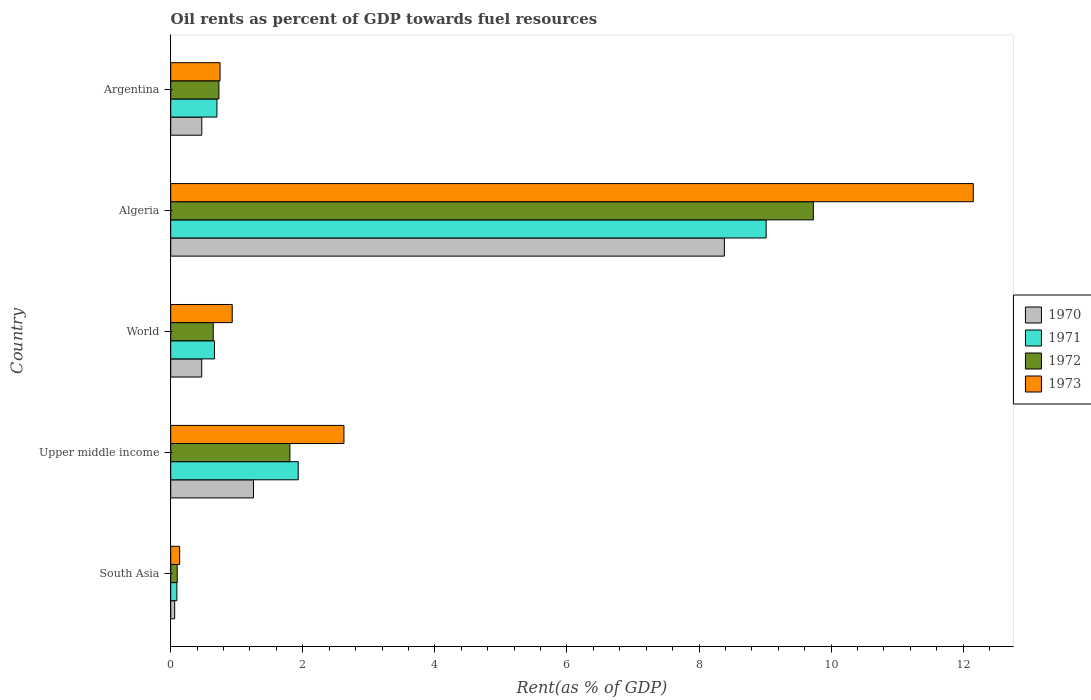How many different coloured bars are there?
Offer a terse response. 4. How many groups of bars are there?
Offer a terse response. 5. Are the number of bars on each tick of the Y-axis equal?
Offer a very short reply. Yes. What is the label of the 2nd group of bars from the top?
Make the answer very short. Algeria. What is the oil rent in 1970 in Upper middle income?
Your answer should be very brief. 1.25. Across all countries, what is the maximum oil rent in 1972?
Keep it short and to the point. 9.73. Across all countries, what is the minimum oil rent in 1973?
Give a very brief answer. 0.14. In which country was the oil rent in 1970 maximum?
Offer a terse response. Algeria. In which country was the oil rent in 1970 minimum?
Provide a succinct answer. South Asia. What is the total oil rent in 1973 in the graph?
Offer a very short reply. 16.59. What is the difference between the oil rent in 1973 in South Asia and that in World?
Ensure brevity in your answer.  -0.8. What is the difference between the oil rent in 1971 in South Asia and the oil rent in 1973 in World?
Provide a succinct answer. -0.84. What is the average oil rent in 1972 per country?
Your answer should be very brief. 2.6. What is the difference between the oil rent in 1972 and oil rent in 1970 in World?
Provide a short and direct response. 0.17. What is the ratio of the oil rent in 1972 in Argentina to that in Upper middle income?
Make the answer very short. 0.4. What is the difference between the highest and the second highest oil rent in 1971?
Your answer should be compact. 7.09. What is the difference between the highest and the lowest oil rent in 1972?
Give a very brief answer. 9.63. Is the sum of the oil rent in 1970 in Argentina and World greater than the maximum oil rent in 1971 across all countries?
Keep it short and to the point. No. Is it the case that in every country, the sum of the oil rent in 1972 and oil rent in 1970 is greater than the sum of oil rent in 1973 and oil rent in 1971?
Ensure brevity in your answer.  No. What does the 2nd bar from the bottom in Upper middle income represents?
Give a very brief answer. 1971. How many bars are there?
Provide a succinct answer. 20. What is the difference between two consecutive major ticks on the X-axis?
Ensure brevity in your answer.  2. Does the graph contain any zero values?
Offer a very short reply. No. Does the graph contain grids?
Ensure brevity in your answer.  No. Where does the legend appear in the graph?
Keep it short and to the point. Center right. How many legend labels are there?
Offer a very short reply. 4. What is the title of the graph?
Offer a very short reply. Oil rents as percent of GDP towards fuel resources. Does "1961" appear as one of the legend labels in the graph?
Your answer should be compact. No. What is the label or title of the X-axis?
Your answer should be very brief. Rent(as % of GDP). What is the Rent(as % of GDP) in 1970 in South Asia?
Ensure brevity in your answer.  0.06. What is the Rent(as % of GDP) of 1971 in South Asia?
Offer a very short reply. 0.09. What is the Rent(as % of GDP) of 1972 in South Asia?
Make the answer very short. 0.1. What is the Rent(as % of GDP) of 1973 in South Asia?
Your response must be concise. 0.14. What is the Rent(as % of GDP) of 1970 in Upper middle income?
Provide a short and direct response. 1.25. What is the Rent(as % of GDP) in 1971 in Upper middle income?
Ensure brevity in your answer.  1.93. What is the Rent(as % of GDP) of 1972 in Upper middle income?
Provide a succinct answer. 1.8. What is the Rent(as % of GDP) in 1973 in Upper middle income?
Make the answer very short. 2.62. What is the Rent(as % of GDP) of 1970 in World?
Offer a very short reply. 0.47. What is the Rent(as % of GDP) of 1971 in World?
Your answer should be very brief. 0.66. What is the Rent(as % of GDP) in 1972 in World?
Make the answer very short. 0.64. What is the Rent(as % of GDP) of 1973 in World?
Make the answer very short. 0.93. What is the Rent(as % of GDP) in 1970 in Algeria?
Your answer should be very brief. 8.38. What is the Rent(as % of GDP) of 1971 in Algeria?
Provide a short and direct response. 9.02. What is the Rent(as % of GDP) of 1972 in Algeria?
Keep it short and to the point. 9.73. What is the Rent(as % of GDP) in 1973 in Algeria?
Give a very brief answer. 12.15. What is the Rent(as % of GDP) in 1970 in Argentina?
Provide a short and direct response. 0.47. What is the Rent(as % of GDP) in 1971 in Argentina?
Provide a short and direct response. 0.7. What is the Rent(as % of GDP) of 1972 in Argentina?
Make the answer very short. 0.73. What is the Rent(as % of GDP) in 1973 in Argentina?
Provide a succinct answer. 0.75. Across all countries, what is the maximum Rent(as % of GDP) of 1970?
Make the answer very short. 8.38. Across all countries, what is the maximum Rent(as % of GDP) in 1971?
Your response must be concise. 9.02. Across all countries, what is the maximum Rent(as % of GDP) in 1972?
Your answer should be very brief. 9.73. Across all countries, what is the maximum Rent(as % of GDP) in 1973?
Keep it short and to the point. 12.15. Across all countries, what is the minimum Rent(as % of GDP) of 1970?
Provide a succinct answer. 0.06. Across all countries, what is the minimum Rent(as % of GDP) of 1971?
Your response must be concise. 0.09. Across all countries, what is the minimum Rent(as % of GDP) of 1972?
Ensure brevity in your answer.  0.1. Across all countries, what is the minimum Rent(as % of GDP) of 1973?
Provide a short and direct response. 0.14. What is the total Rent(as % of GDP) of 1970 in the graph?
Give a very brief answer. 10.64. What is the total Rent(as % of GDP) in 1971 in the graph?
Keep it short and to the point. 12.4. What is the total Rent(as % of GDP) of 1972 in the graph?
Your response must be concise. 13.01. What is the total Rent(as % of GDP) in 1973 in the graph?
Provide a short and direct response. 16.59. What is the difference between the Rent(as % of GDP) in 1970 in South Asia and that in Upper middle income?
Give a very brief answer. -1.19. What is the difference between the Rent(as % of GDP) in 1971 in South Asia and that in Upper middle income?
Your answer should be very brief. -1.84. What is the difference between the Rent(as % of GDP) in 1972 in South Asia and that in Upper middle income?
Provide a succinct answer. -1.71. What is the difference between the Rent(as % of GDP) in 1973 in South Asia and that in Upper middle income?
Offer a very short reply. -2.49. What is the difference between the Rent(as % of GDP) in 1970 in South Asia and that in World?
Your answer should be very brief. -0.41. What is the difference between the Rent(as % of GDP) in 1971 in South Asia and that in World?
Provide a succinct answer. -0.57. What is the difference between the Rent(as % of GDP) in 1972 in South Asia and that in World?
Make the answer very short. -0.55. What is the difference between the Rent(as % of GDP) in 1973 in South Asia and that in World?
Your response must be concise. -0.8. What is the difference between the Rent(as % of GDP) of 1970 in South Asia and that in Algeria?
Ensure brevity in your answer.  -8.32. What is the difference between the Rent(as % of GDP) of 1971 in South Asia and that in Algeria?
Provide a succinct answer. -8.92. What is the difference between the Rent(as % of GDP) in 1972 in South Asia and that in Algeria?
Provide a succinct answer. -9.63. What is the difference between the Rent(as % of GDP) of 1973 in South Asia and that in Algeria?
Your response must be concise. -12.02. What is the difference between the Rent(as % of GDP) in 1970 in South Asia and that in Argentina?
Your answer should be compact. -0.41. What is the difference between the Rent(as % of GDP) in 1971 in South Asia and that in Argentina?
Provide a short and direct response. -0.61. What is the difference between the Rent(as % of GDP) of 1972 in South Asia and that in Argentina?
Provide a short and direct response. -0.63. What is the difference between the Rent(as % of GDP) in 1973 in South Asia and that in Argentina?
Your answer should be compact. -0.61. What is the difference between the Rent(as % of GDP) of 1970 in Upper middle income and that in World?
Offer a very short reply. 0.78. What is the difference between the Rent(as % of GDP) in 1971 in Upper middle income and that in World?
Your response must be concise. 1.27. What is the difference between the Rent(as % of GDP) in 1972 in Upper middle income and that in World?
Your answer should be very brief. 1.16. What is the difference between the Rent(as % of GDP) in 1973 in Upper middle income and that in World?
Ensure brevity in your answer.  1.69. What is the difference between the Rent(as % of GDP) in 1970 in Upper middle income and that in Algeria?
Offer a terse response. -7.13. What is the difference between the Rent(as % of GDP) in 1971 in Upper middle income and that in Algeria?
Provide a short and direct response. -7.09. What is the difference between the Rent(as % of GDP) in 1972 in Upper middle income and that in Algeria?
Make the answer very short. -7.93. What is the difference between the Rent(as % of GDP) in 1973 in Upper middle income and that in Algeria?
Your answer should be compact. -9.53. What is the difference between the Rent(as % of GDP) of 1970 in Upper middle income and that in Argentina?
Ensure brevity in your answer.  0.78. What is the difference between the Rent(as % of GDP) in 1971 in Upper middle income and that in Argentina?
Keep it short and to the point. 1.23. What is the difference between the Rent(as % of GDP) of 1972 in Upper middle income and that in Argentina?
Ensure brevity in your answer.  1.07. What is the difference between the Rent(as % of GDP) of 1973 in Upper middle income and that in Argentina?
Offer a very short reply. 1.88. What is the difference between the Rent(as % of GDP) of 1970 in World and that in Algeria?
Offer a terse response. -7.91. What is the difference between the Rent(as % of GDP) in 1971 in World and that in Algeria?
Provide a succinct answer. -8.35. What is the difference between the Rent(as % of GDP) of 1972 in World and that in Algeria?
Your answer should be very brief. -9.09. What is the difference between the Rent(as % of GDP) in 1973 in World and that in Algeria?
Offer a very short reply. -11.22. What is the difference between the Rent(as % of GDP) of 1970 in World and that in Argentina?
Make the answer very short. -0. What is the difference between the Rent(as % of GDP) in 1971 in World and that in Argentina?
Offer a very short reply. -0.04. What is the difference between the Rent(as % of GDP) of 1972 in World and that in Argentina?
Ensure brevity in your answer.  -0.09. What is the difference between the Rent(as % of GDP) in 1973 in World and that in Argentina?
Make the answer very short. 0.18. What is the difference between the Rent(as % of GDP) in 1970 in Algeria and that in Argentina?
Your answer should be compact. 7.91. What is the difference between the Rent(as % of GDP) of 1971 in Algeria and that in Argentina?
Ensure brevity in your answer.  8.32. What is the difference between the Rent(as % of GDP) in 1972 in Algeria and that in Argentina?
Ensure brevity in your answer.  9. What is the difference between the Rent(as % of GDP) of 1973 in Algeria and that in Argentina?
Keep it short and to the point. 11.41. What is the difference between the Rent(as % of GDP) of 1970 in South Asia and the Rent(as % of GDP) of 1971 in Upper middle income?
Your answer should be very brief. -1.87. What is the difference between the Rent(as % of GDP) in 1970 in South Asia and the Rent(as % of GDP) in 1972 in Upper middle income?
Provide a succinct answer. -1.74. What is the difference between the Rent(as % of GDP) in 1970 in South Asia and the Rent(as % of GDP) in 1973 in Upper middle income?
Your response must be concise. -2.56. What is the difference between the Rent(as % of GDP) of 1971 in South Asia and the Rent(as % of GDP) of 1972 in Upper middle income?
Provide a succinct answer. -1.71. What is the difference between the Rent(as % of GDP) of 1971 in South Asia and the Rent(as % of GDP) of 1973 in Upper middle income?
Provide a succinct answer. -2.53. What is the difference between the Rent(as % of GDP) of 1972 in South Asia and the Rent(as % of GDP) of 1973 in Upper middle income?
Your answer should be compact. -2.52. What is the difference between the Rent(as % of GDP) in 1970 in South Asia and the Rent(as % of GDP) in 1971 in World?
Offer a terse response. -0.6. What is the difference between the Rent(as % of GDP) of 1970 in South Asia and the Rent(as % of GDP) of 1972 in World?
Your response must be concise. -0.58. What is the difference between the Rent(as % of GDP) of 1970 in South Asia and the Rent(as % of GDP) of 1973 in World?
Your answer should be compact. -0.87. What is the difference between the Rent(as % of GDP) in 1971 in South Asia and the Rent(as % of GDP) in 1972 in World?
Offer a very short reply. -0.55. What is the difference between the Rent(as % of GDP) of 1971 in South Asia and the Rent(as % of GDP) of 1973 in World?
Offer a terse response. -0.84. What is the difference between the Rent(as % of GDP) of 1972 in South Asia and the Rent(as % of GDP) of 1973 in World?
Keep it short and to the point. -0.83. What is the difference between the Rent(as % of GDP) of 1970 in South Asia and the Rent(as % of GDP) of 1971 in Algeria?
Ensure brevity in your answer.  -8.96. What is the difference between the Rent(as % of GDP) of 1970 in South Asia and the Rent(as % of GDP) of 1972 in Algeria?
Give a very brief answer. -9.67. What is the difference between the Rent(as % of GDP) in 1970 in South Asia and the Rent(as % of GDP) in 1973 in Algeria?
Your answer should be very brief. -12.09. What is the difference between the Rent(as % of GDP) in 1971 in South Asia and the Rent(as % of GDP) in 1972 in Algeria?
Provide a short and direct response. -9.64. What is the difference between the Rent(as % of GDP) of 1971 in South Asia and the Rent(as % of GDP) of 1973 in Algeria?
Your answer should be compact. -12.06. What is the difference between the Rent(as % of GDP) in 1972 in South Asia and the Rent(as % of GDP) in 1973 in Algeria?
Ensure brevity in your answer.  -12.05. What is the difference between the Rent(as % of GDP) of 1970 in South Asia and the Rent(as % of GDP) of 1971 in Argentina?
Provide a succinct answer. -0.64. What is the difference between the Rent(as % of GDP) in 1970 in South Asia and the Rent(as % of GDP) in 1972 in Argentina?
Provide a short and direct response. -0.67. What is the difference between the Rent(as % of GDP) in 1970 in South Asia and the Rent(as % of GDP) in 1973 in Argentina?
Provide a short and direct response. -0.69. What is the difference between the Rent(as % of GDP) of 1971 in South Asia and the Rent(as % of GDP) of 1972 in Argentina?
Make the answer very short. -0.64. What is the difference between the Rent(as % of GDP) of 1971 in South Asia and the Rent(as % of GDP) of 1973 in Argentina?
Offer a very short reply. -0.65. What is the difference between the Rent(as % of GDP) of 1972 in South Asia and the Rent(as % of GDP) of 1973 in Argentina?
Your answer should be compact. -0.65. What is the difference between the Rent(as % of GDP) in 1970 in Upper middle income and the Rent(as % of GDP) in 1971 in World?
Offer a terse response. 0.59. What is the difference between the Rent(as % of GDP) of 1970 in Upper middle income and the Rent(as % of GDP) of 1972 in World?
Your response must be concise. 0.61. What is the difference between the Rent(as % of GDP) in 1970 in Upper middle income and the Rent(as % of GDP) in 1973 in World?
Your answer should be compact. 0.32. What is the difference between the Rent(as % of GDP) in 1971 in Upper middle income and the Rent(as % of GDP) in 1972 in World?
Provide a succinct answer. 1.29. What is the difference between the Rent(as % of GDP) of 1971 in Upper middle income and the Rent(as % of GDP) of 1973 in World?
Make the answer very short. 1. What is the difference between the Rent(as % of GDP) in 1972 in Upper middle income and the Rent(as % of GDP) in 1973 in World?
Your answer should be very brief. 0.87. What is the difference between the Rent(as % of GDP) of 1970 in Upper middle income and the Rent(as % of GDP) of 1971 in Algeria?
Ensure brevity in your answer.  -7.76. What is the difference between the Rent(as % of GDP) in 1970 in Upper middle income and the Rent(as % of GDP) in 1972 in Algeria?
Offer a very short reply. -8.48. What is the difference between the Rent(as % of GDP) in 1970 in Upper middle income and the Rent(as % of GDP) in 1973 in Algeria?
Provide a succinct answer. -10.9. What is the difference between the Rent(as % of GDP) in 1971 in Upper middle income and the Rent(as % of GDP) in 1973 in Algeria?
Give a very brief answer. -10.22. What is the difference between the Rent(as % of GDP) of 1972 in Upper middle income and the Rent(as % of GDP) of 1973 in Algeria?
Provide a succinct answer. -10.35. What is the difference between the Rent(as % of GDP) of 1970 in Upper middle income and the Rent(as % of GDP) of 1971 in Argentina?
Ensure brevity in your answer.  0.55. What is the difference between the Rent(as % of GDP) of 1970 in Upper middle income and the Rent(as % of GDP) of 1972 in Argentina?
Offer a very short reply. 0.52. What is the difference between the Rent(as % of GDP) of 1970 in Upper middle income and the Rent(as % of GDP) of 1973 in Argentina?
Keep it short and to the point. 0.51. What is the difference between the Rent(as % of GDP) of 1971 in Upper middle income and the Rent(as % of GDP) of 1972 in Argentina?
Your answer should be very brief. 1.2. What is the difference between the Rent(as % of GDP) of 1971 in Upper middle income and the Rent(as % of GDP) of 1973 in Argentina?
Keep it short and to the point. 1.18. What is the difference between the Rent(as % of GDP) in 1972 in Upper middle income and the Rent(as % of GDP) in 1973 in Argentina?
Your response must be concise. 1.06. What is the difference between the Rent(as % of GDP) of 1970 in World and the Rent(as % of GDP) of 1971 in Algeria?
Offer a terse response. -8.55. What is the difference between the Rent(as % of GDP) of 1970 in World and the Rent(as % of GDP) of 1972 in Algeria?
Offer a terse response. -9.26. What is the difference between the Rent(as % of GDP) of 1970 in World and the Rent(as % of GDP) of 1973 in Algeria?
Make the answer very short. -11.68. What is the difference between the Rent(as % of GDP) of 1971 in World and the Rent(as % of GDP) of 1972 in Algeria?
Your answer should be compact. -9.07. What is the difference between the Rent(as % of GDP) in 1971 in World and the Rent(as % of GDP) in 1973 in Algeria?
Make the answer very short. -11.49. What is the difference between the Rent(as % of GDP) of 1972 in World and the Rent(as % of GDP) of 1973 in Algeria?
Make the answer very short. -11.51. What is the difference between the Rent(as % of GDP) of 1970 in World and the Rent(as % of GDP) of 1971 in Argentina?
Offer a very short reply. -0.23. What is the difference between the Rent(as % of GDP) of 1970 in World and the Rent(as % of GDP) of 1972 in Argentina?
Your answer should be very brief. -0.26. What is the difference between the Rent(as % of GDP) in 1970 in World and the Rent(as % of GDP) in 1973 in Argentina?
Give a very brief answer. -0.28. What is the difference between the Rent(as % of GDP) in 1971 in World and the Rent(as % of GDP) in 1972 in Argentina?
Ensure brevity in your answer.  -0.07. What is the difference between the Rent(as % of GDP) in 1971 in World and the Rent(as % of GDP) in 1973 in Argentina?
Your response must be concise. -0.08. What is the difference between the Rent(as % of GDP) of 1972 in World and the Rent(as % of GDP) of 1973 in Argentina?
Keep it short and to the point. -0.1. What is the difference between the Rent(as % of GDP) of 1970 in Algeria and the Rent(as % of GDP) of 1971 in Argentina?
Your response must be concise. 7.68. What is the difference between the Rent(as % of GDP) of 1970 in Algeria and the Rent(as % of GDP) of 1972 in Argentina?
Make the answer very short. 7.65. What is the difference between the Rent(as % of GDP) of 1970 in Algeria and the Rent(as % of GDP) of 1973 in Argentina?
Provide a short and direct response. 7.64. What is the difference between the Rent(as % of GDP) of 1971 in Algeria and the Rent(as % of GDP) of 1972 in Argentina?
Offer a very short reply. 8.29. What is the difference between the Rent(as % of GDP) in 1971 in Algeria and the Rent(as % of GDP) in 1973 in Argentina?
Your answer should be compact. 8.27. What is the difference between the Rent(as % of GDP) in 1972 in Algeria and the Rent(as % of GDP) in 1973 in Argentina?
Give a very brief answer. 8.98. What is the average Rent(as % of GDP) in 1970 per country?
Provide a succinct answer. 2.13. What is the average Rent(as % of GDP) of 1971 per country?
Keep it short and to the point. 2.48. What is the average Rent(as % of GDP) in 1972 per country?
Keep it short and to the point. 2.6. What is the average Rent(as % of GDP) of 1973 per country?
Provide a succinct answer. 3.32. What is the difference between the Rent(as % of GDP) of 1970 and Rent(as % of GDP) of 1971 in South Asia?
Give a very brief answer. -0.03. What is the difference between the Rent(as % of GDP) of 1970 and Rent(as % of GDP) of 1972 in South Asia?
Your response must be concise. -0.04. What is the difference between the Rent(as % of GDP) in 1970 and Rent(as % of GDP) in 1973 in South Asia?
Provide a succinct answer. -0.08. What is the difference between the Rent(as % of GDP) of 1971 and Rent(as % of GDP) of 1972 in South Asia?
Provide a succinct answer. -0.01. What is the difference between the Rent(as % of GDP) in 1971 and Rent(as % of GDP) in 1973 in South Asia?
Keep it short and to the point. -0.04. What is the difference between the Rent(as % of GDP) in 1972 and Rent(as % of GDP) in 1973 in South Asia?
Keep it short and to the point. -0.04. What is the difference between the Rent(as % of GDP) in 1970 and Rent(as % of GDP) in 1971 in Upper middle income?
Ensure brevity in your answer.  -0.68. What is the difference between the Rent(as % of GDP) of 1970 and Rent(as % of GDP) of 1972 in Upper middle income?
Provide a succinct answer. -0.55. What is the difference between the Rent(as % of GDP) in 1970 and Rent(as % of GDP) in 1973 in Upper middle income?
Ensure brevity in your answer.  -1.37. What is the difference between the Rent(as % of GDP) of 1971 and Rent(as % of GDP) of 1972 in Upper middle income?
Ensure brevity in your answer.  0.13. What is the difference between the Rent(as % of GDP) in 1971 and Rent(as % of GDP) in 1973 in Upper middle income?
Offer a very short reply. -0.69. What is the difference between the Rent(as % of GDP) in 1972 and Rent(as % of GDP) in 1973 in Upper middle income?
Provide a short and direct response. -0.82. What is the difference between the Rent(as % of GDP) of 1970 and Rent(as % of GDP) of 1971 in World?
Your response must be concise. -0.19. What is the difference between the Rent(as % of GDP) of 1970 and Rent(as % of GDP) of 1972 in World?
Make the answer very short. -0.17. What is the difference between the Rent(as % of GDP) of 1970 and Rent(as % of GDP) of 1973 in World?
Your response must be concise. -0.46. What is the difference between the Rent(as % of GDP) in 1971 and Rent(as % of GDP) in 1972 in World?
Your answer should be compact. 0.02. What is the difference between the Rent(as % of GDP) of 1971 and Rent(as % of GDP) of 1973 in World?
Ensure brevity in your answer.  -0.27. What is the difference between the Rent(as % of GDP) in 1972 and Rent(as % of GDP) in 1973 in World?
Provide a succinct answer. -0.29. What is the difference between the Rent(as % of GDP) in 1970 and Rent(as % of GDP) in 1971 in Algeria?
Offer a terse response. -0.63. What is the difference between the Rent(as % of GDP) in 1970 and Rent(as % of GDP) in 1972 in Algeria?
Ensure brevity in your answer.  -1.35. What is the difference between the Rent(as % of GDP) in 1970 and Rent(as % of GDP) in 1973 in Algeria?
Ensure brevity in your answer.  -3.77. What is the difference between the Rent(as % of GDP) of 1971 and Rent(as % of GDP) of 1972 in Algeria?
Provide a short and direct response. -0.71. What is the difference between the Rent(as % of GDP) of 1971 and Rent(as % of GDP) of 1973 in Algeria?
Make the answer very short. -3.14. What is the difference between the Rent(as % of GDP) of 1972 and Rent(as % of GDP) of 1973 in Algeria?
Your answer should be compact. -2.42. What is the difference between the Rent(as % of GDP) of 1970 and Rent(as % of GDP) of 1971 in Argentina?
Your response must be concise. -0.23. What is the difference between the Rent(as % of GDP) of 1970 and Rent(as % of GDP) of 1972 in Argentina?
Ensure brevity in your answer.  -0.26. What is the difference between the Rent(as % of GDP) of 1970 and Rent(as % of GDP) of 1973 in Argentina?
Offer a very short reply. -0.28. What is the difference between the Rent(as % of GDP) in 1971 and Rent(as % of GDP) in 1972 in Argentina?
Make the answer very short. -0.03. What is the difference between the Rent(as % of GDP) in 1971 and Rent(as % of GDP) in 1973 in Argentina?
Your answer should be compact. -0.05. What is the difference between the Rent(as % of GDP) of 1972 and Rent(as % of GDP) of 1973 in Argentina?
Provide a short and direct response. -0.02. What is the ratio of the Rent(as % of GDP) of 1970 in South Asia to that in Upper middle income?
Keep it short and to the point. 0.05. What is the ratio of the Rent(as % of GDP) of 1971 in South Asia to that in Upper middle income?
Offer a terse response. 0.05. What is the ratio of the Rent(as % of GDP) in 1972 in South Asia to that in Upper middle income?
Provide a short and direct response. 0.05. What is the ratio of the Rent(as % of GDP) in 1973 in South Asia to that in Upper middle income?
Keep it short and to the point. 0.05. What is the ratio of the Rent(as % of GDP) in 1970 in South Asia to that in World?
Ensure brevity in your answer.  0.13. What is the ratio of the Rent(as % of GDP) in 1971 in South Asia to that in World?
Keep it short and to the point. 0.14. What is the ratio of the Rent(as % of GDP) in 1972 in South Asia to that in World?
Provide a short and direct response. 0.15. What is the ratio of the Rent(as % of GDP) of 1973 in South Asia to that in World?
Provide a succinct answer. 0.14. What is the ratio of the Rent(as % of GDP) in 1970 in South Asia to that in Algeria?
Your answer should be very brief. 0.01. What is the ratio of the Rent(as % of GDP) of 1971 in South Asia to that in Algeria?
Give a very brief answer. 0.01. What is the ratio of the Rent(as % of GDP) in 1972 in South Asia to that in Algeria?
Make the answer very short. 0.01. What is the ratio of the Rent(as % of GDP) of 1973 in South Asia to that in Algeria?
Your response must be concise. 0.01. What is the ratio of the Rent(as % of GDP) in 1970 in South Asia to that in Argentina?
Offer a very short reply. 0.13. What is the ratio of the Rent(as % of GDP) in 1971 in South Asia to that in Argentina?
Your answer should be very brief. 0.13. What is the ratio of the Rent(as % of GDP) in 1972 in South Asia to that in Argentina?
Your answer should be very brief. 0.14. What is the ratio of the Rent(as % of GDP) in 1973 in South Asia to that in Argentina?
Make the answer very short. 0.18. What is the ratio of the Rent(as % of GDP) of 1970 in Upper middle income to that in World?
Give a very brief answer. 2.67. What is the ratio of the Rent(as % of GDP) of 1971 in Upper middle income to that in World?
Provide a short and direct response. 2.91. What is the ratio of the Rent(as % of GDP) in 1972 in Upper middle income to that in World?
Make the answer very short. 2.8. What is the ratio of the Rent(as % of GDP) in 1973 in Upper middle income to that in World?
Your answer should be compact. 2.82. What is the ratio of the Rent(as % of GDP) in 1970 in Upper middle income to that in Algeria?
Provide a succinct answer. 0.15. What is the ratio of the Rent(as % of GDP) of 1971 in Upper middle income to that in Algeria?
Your answer should be very brief. 0.21. What is the ratio of the Rent(as % of GDP) in 1972 in Upper middle income to that in Algeria?
Make the answer very short. 0.19. What is the ratio of the Rent(as % of GDP) of 1973 in Upper middle income to that in Algeria?
Ensure brevity in your answer.  0.22. What is the ratio of the Rent(as % of GDP) in 1970 in Upper middle income to that in Argentina?
Your response must be concise. 2.67. What is the ratio of the Rent(as % of GDP) of 1971 in Upper middle income to that in Argentina?
Give a very brief answer. 2.76. What is the ratio of the Rent(as % of GDP) of 1972 in Upper middle income to that in Argentina?
Your response must be concise. 2.47. What is the ratio of the Rent(as % of GDP) of 1973 in Upper middle income to that in Argentina?
Keep it short and to the point. 3.51. What is the ratio of the Rent(as % of GDP) in 1970 in World to that in Algeria?
Your response must be concise. 0.06. What is the ratio of the Rent(as % of GDP) of 1971 in World to that in Algeria?
Ensure brevity in your answer.  0.07. What is the ratio of the Rent(as % of GDP) of 1972 in World to that in Algeria?
Provide a short and direct response. 0.07. What is the ratio of the Rent(as % of GDP) of 1973 in World to that in Algeria?
Your response must be concise. 0.08. What is the ratio of the Rent(as % of GDP) of 1971 in World to that in Argentina?
Keep it short and to the point. 0.95. What is the ratio of the Rent(as % of GDP) of 1972 in World to that in Argentina?
Provide a short and direct response. 0.88. What is the ratio of the Rent(as % of GDP) of 1973 in World to that in Argentina?
Offer a very short reply. 1.25. What is the ratio of the Rent(as % of GDP) of 1970 in Algeria to that in Argentina?
Offer a terse response. 17.83. What is the ratio of the Rent(as % of GDP) of 1971 in Algeria to that in Argentina?
Offer a very short reply. 12.88. What is the ratio of the Rent(as % of GDP) of 1972 in Algeria to that in Argentina?
Your response must be concise. 13.33. What is the ratio of the Rent(as % of GDP) of 1973 in Algeria to that in Argentina?
Provide a short and direct response. 16.27. What is the difference between the highest and the second highest Rent(as % of GDP) in 1970?
Make the answer very short. 7.13. What is the difference between the highest and the second highest Rent(as % of GDP) in 1971?
Your answer should be very brief. 7.09. What is the difference between the highest and the second highest Rent(as % of GDP) in 1972?
Offer a terse response. 7.93. What is the difference between the highest and the second highest Rent(as % of GDP) of 1973?
Make the answer very short. 9.53. What is the difference between the highest and the lowest Rent(as % of GDP) of 1970?
Your answer should be compact. 8.32. What is the difference between the highest and the lowest Rent(as % of GDP) in 1971?
Make the answer very short. 8.92. What is the difference between the highest and the lowest Rent(as % of GDP) of 1972?
Ensure brevity in your answer.  9.63. What is the difference between the highest and the lowest Rent(as % of GDP) of 1973?
Ensure brevity in your answer.  12.02. 